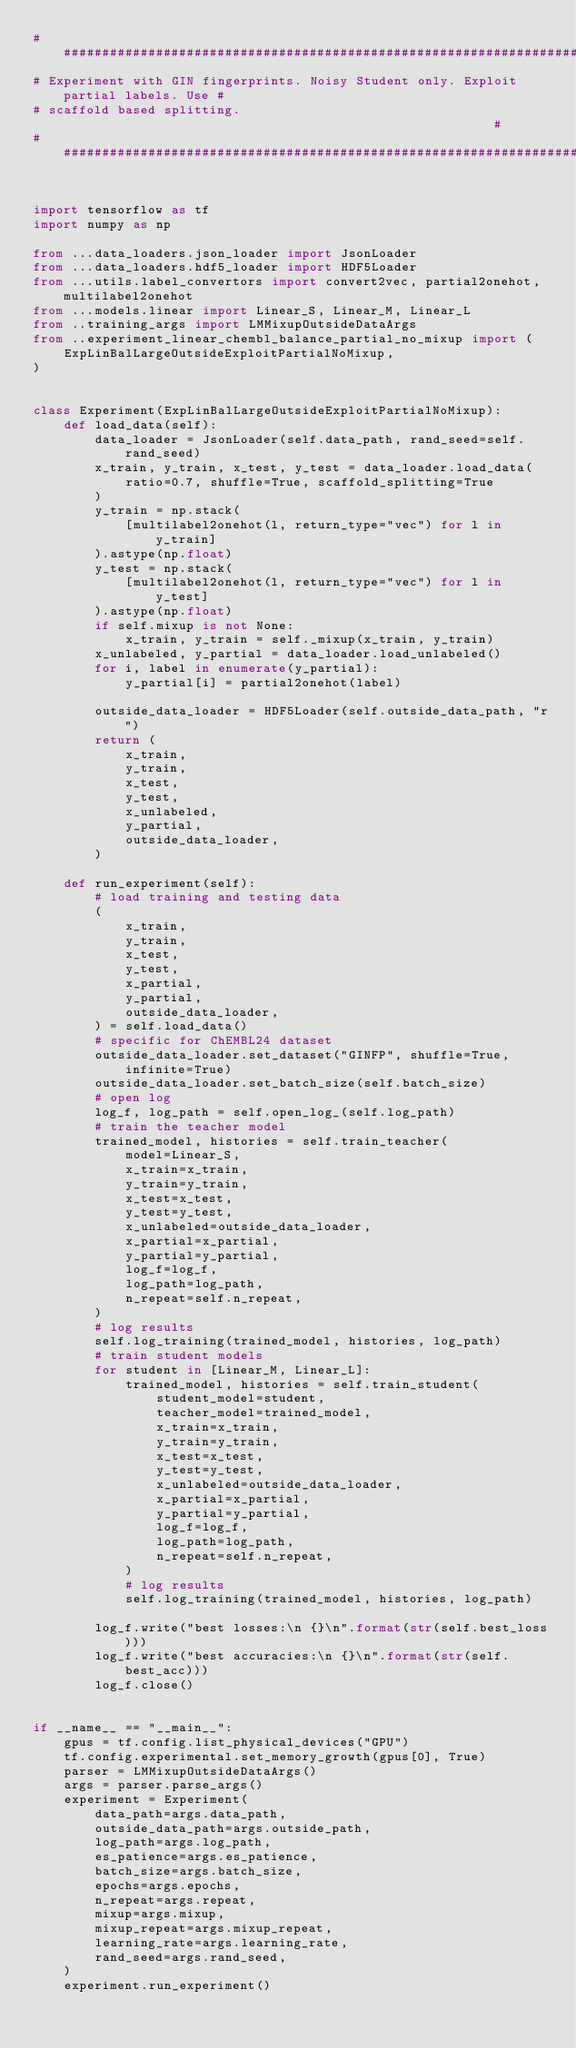<code> <loc_0><loc_0><loc_500><loc_500><_Python_>#####################################################################################
# Experiment with GIN fingerprints. Noisy Student only. Exploit partial labels. Use #
# scaffold based splitting.                                                         #
#####################################################################################


import tensorflow as tf
import numpy as np

from ...data_loaders.json_loader import JsonLoader
from ...data_loaders.hdf5_loader import HDF5Loader
from ...utils.label_convertors import convert2vec, partial2onehot, multilabel2onehot
from ...models.linear import Linear_S, Linear_M, Linear_L
from ..training_args import LMMixupOutsideDataArgs
from ..experiment_linear_chembl_balance_partial_no_mixup import (
    ExpLinBalLargeOutsideExploitPartialNoMixup,
)


class Experiment(ExpLinBalLargeOutsideExploitPartialNoMixup):
    def load_data(self):
        data_loader = JsonLoader(self.data_path, rand_seed=self.rand_seed)
        x_train, y_train, x_test, y_test = data_loader.load_data(
            ratio=0.7, shuffle=True, scaffold_splitting=True
        )
        y_train = np.stack(
            [multilabel2onehot(l, return_type="vec") for l in y_train]
        ).astype(np.float)
        y_test = np.stack(
            [multilabel2onehot(l, return_type="vec") for l in y_test]
        ).astype(np.float)
        if self.mixup is not None:
            x_train, y_train = self._mixup(x_train, y_train)
        x_unlabeled, y_partial = data_loader.load_unlabeled()
        for i, label in enumerate(y_partial):
            y_partial[i] = partial2onehot(label)

        outside_data_loader = HDF5Loader(self.outside_data_path, "r")
        return (
            x_train,
            y_train,
            x_test,
            y_test,
            x_unlabeled,
            y_partial,
            outside_data_loader,
        )

    def run_experiment(self):
        # load training and testing data
        (
            x_train,
            y_train,
            x_test,
            y_test,
            x_partial,
            y_partial,
            outside_data_loader,
        ) = self.load_data()
        # specific for ChEMBL24 dataset
        outside_data_loader.set_dataset("GINFP", shuffle=True, infinite=True)
        outside_data_loader.set_batch_size(self.batch_size)
        # open log
        log_f, log_path = self.open_log_(self.log_path)
        # train the teacher model
        trained_model, histories = self.train_teacher(
            model=Linear_S,
            x_train=x_train,
            y_train=y_train,
            x_test=x_test,
            y_test=y_test,
            x_unlabeled=outside_data_loader,
            x_partial=x_partial,
            y_partial=y_partial,
            log_f=log_f,
            log_path=log_path,
            n_repeat=self.n_repeat,
        )
        # log results
        self.log_training(trained_model, histories, log_path)
        # train student models
        for student in [Linear_M, Linear_L]:
            trained_model, histories = self.train_student(
                student_model=student,
                teacher_model=trained_model,
                x_train=x_train,
                y_train=y_train,
                x_test=x_test,
                y_test=y_test,
                x_unlabeled=outside_data_loader,
                x_partial=x_partial,
                y_partial=y_partial,
                log_f=log_f,
                log_path=log_path,
                n_repeat=self.n_repeat,
            )
            # log results
            self.log_training(trained_model, histories, log_path)

        log_f.write("best losses:\n {}\n".format(str(self.best_loss)))
        log_f.write("best accuracies:\n {}\n".format(str(self.best_acc)))
        log_f.close()


if __name__ == "__main__":
    gpus = tf.config.list_physical_devices("GPU")
    tf.config.experimental.set_memory_growth(gpus[0], True)
    parser = LMMixupOutsideDataArgs()
    args = parser.parse_args()
    experiment = Experiment(
        data_path=args.data_path,
        outside_data_path=args.outside_path,
        log_path=args.log_path,
        es_patience=args.es_patience,
        batch_size=args.batch_size,
        epochs=args.epochs,
        n_repeat=args.repeat,
        mixup=args.mixup,
        mixup_repeat=args.mixup_repeat,
        learning_rate=args.learning_rate,
        rand_seed=args.rand_seed,
    )
    experiment.run_experiment()
</code> 